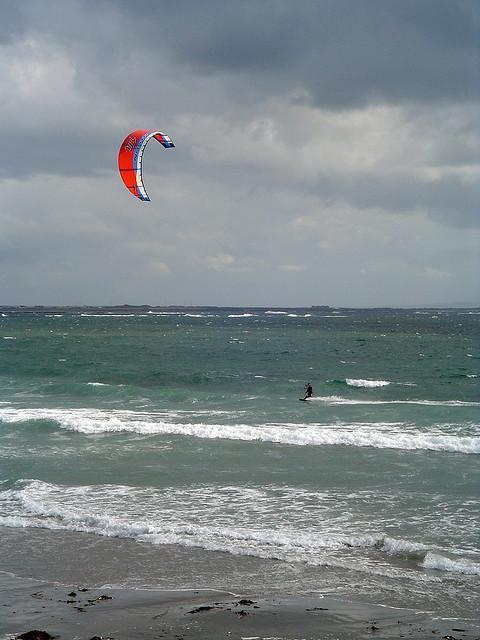What is the boarder about to hit?
Indicate the correct choice and explain in the format: 'Answer: answer
Rationale: rationale.'
Options: Shark, abyss, beach, tidal wave. Answer: beach.
Rationale: The boarder is about to reach the ocean where the beach is. 